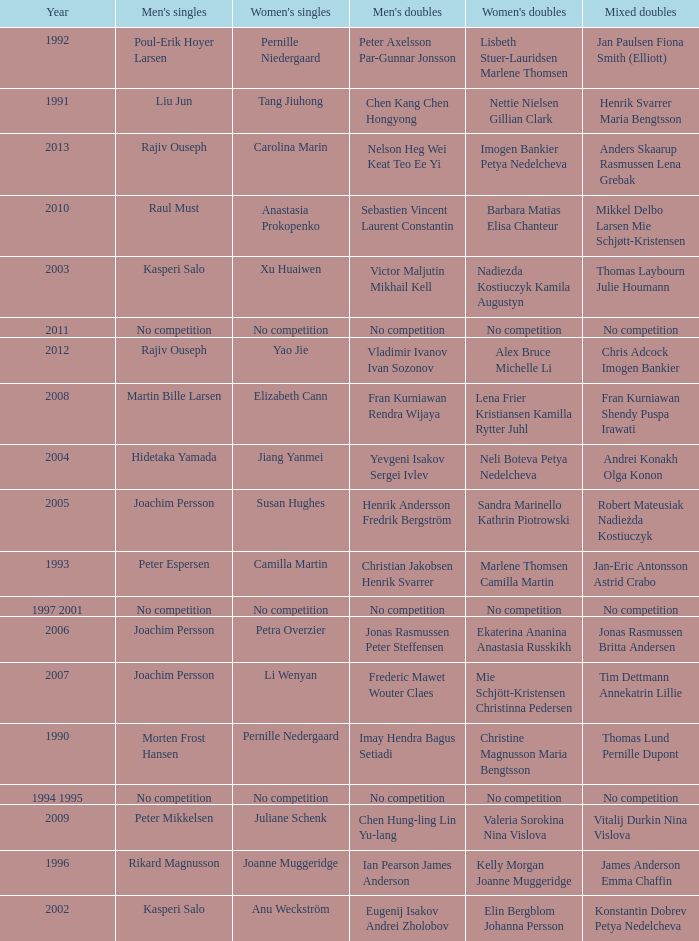Who won the Mixed doubles when Juliane Schenk won the Women's Singles? Vitalij Durkin Nina Vislova. 